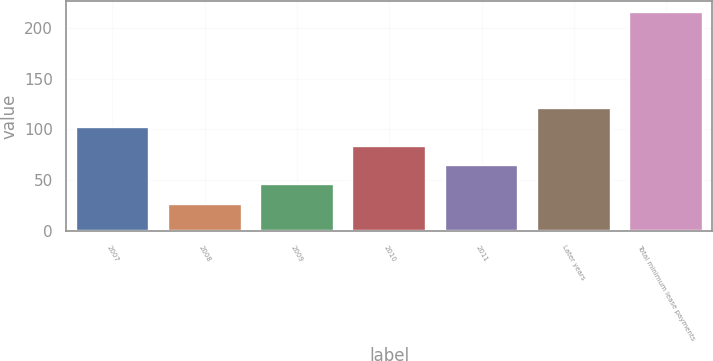Convert chart to OTSL. <chart><loc_0><loc_0><loc_500><loc_500><bar_chart><fcel>2007<fcel>2008<fcel>2009<fcel>2010<fcel>2011<fcel>Later years<fcel>Total minimum lease payments<nl><fcel>102.6<fcel>27<fcel>45.9<fcel>83.7<fcel>64.8<fcel>121.5<fcel>216<nl></chart> 